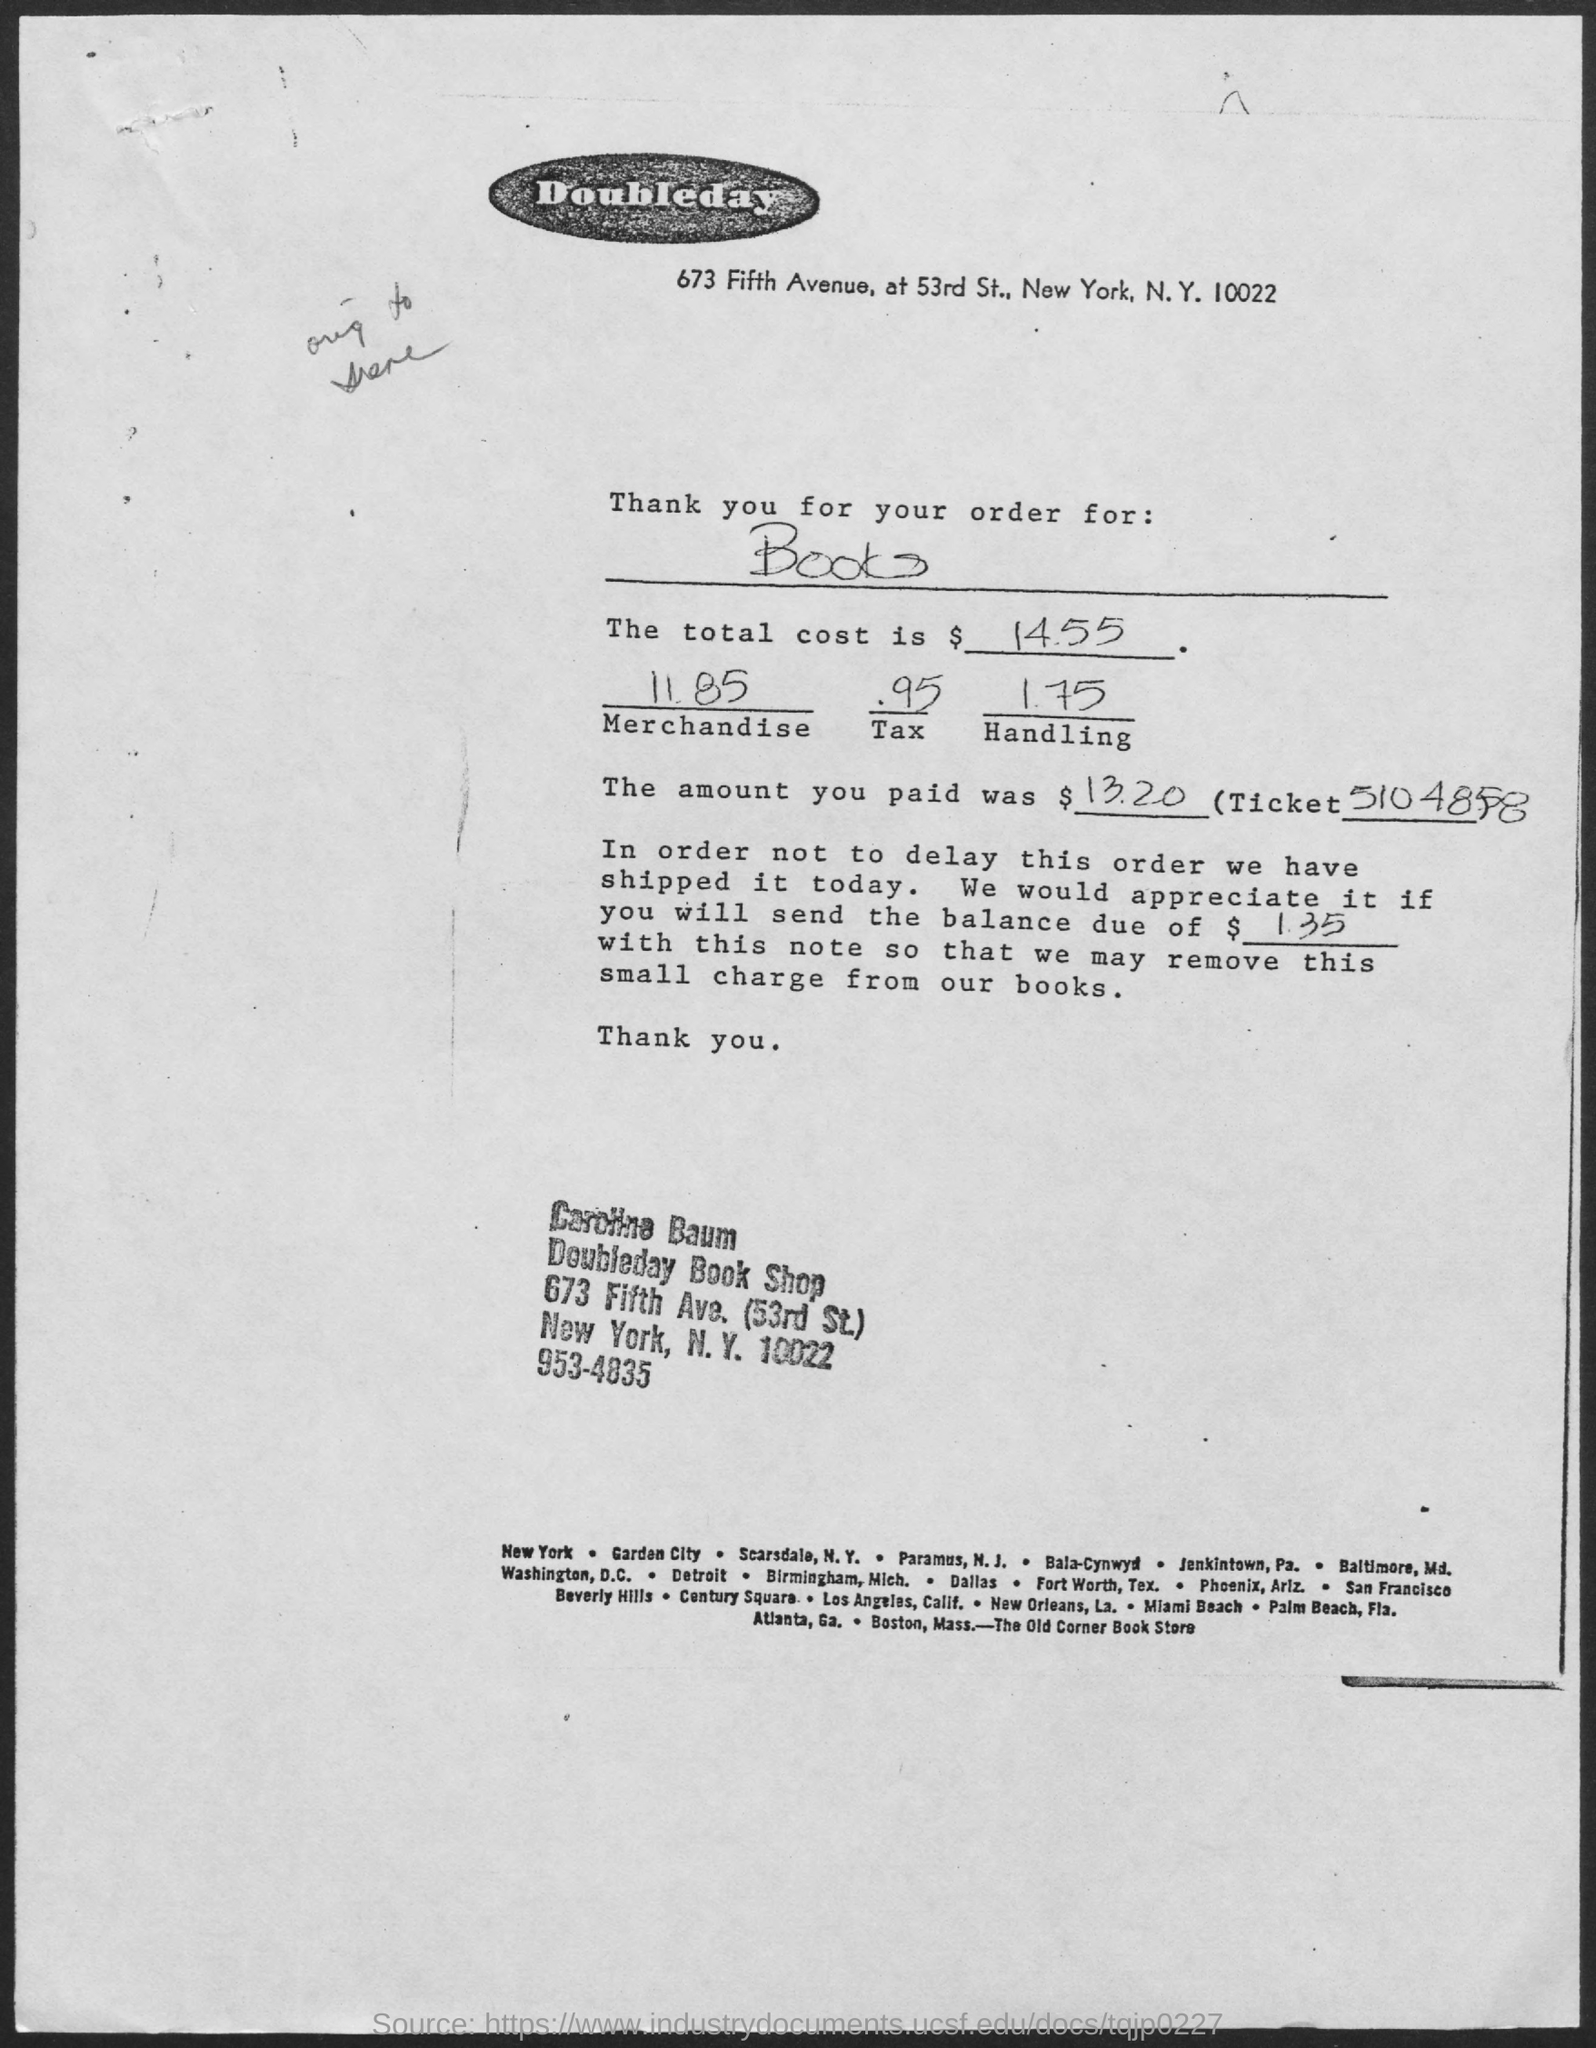What is the Total cost?
Ensure brevity in your answer.  $14.55. What is the cost of the merchandise?
Offer a very short reply. 11.85. What is the Tax?
Your response must be concise. .95. What is the cost of Handling?
Make the answer very short. 1.75. What is the Amount paid?
Offer a terse response. $13.20. What is the ticket number?
Your answer should be very brief. 5104858. 